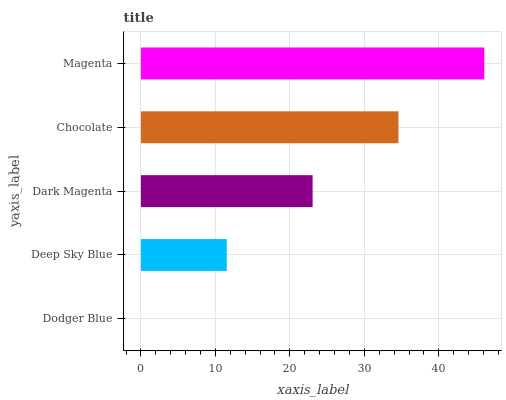Is Dodger Blue the minimum?
Answer yes or no. Yes. Is Magenta the maximum?
Answer yes or no. Yes. Is Deep Sky Blue the minimum?
Answer yes or no. No. Is Deep Sky Blue the maximum?
Answer yes or no. No. Is Deep Sky Blue greater than Dodger Blue?
Answer yes or no. Yes. Is Dodger Blue less than Deep Sky Blue?
Answer yes or no. Yes. Is Dodger Blue greater than Deep Sky Blue?
Answer yes or no. No. Is Deep Sky Blue less than Dodger Blue?
Answer yes or no. No. Is Dark Magenta the high median?
Answer yes or no. Yes. Is Dark Magenta the low median?
Answer yes or no. Yes. Is Chocolate the high median?
Answer yes or no. No. Is Dodger Blue the low median?
Answer yes or no. No. 